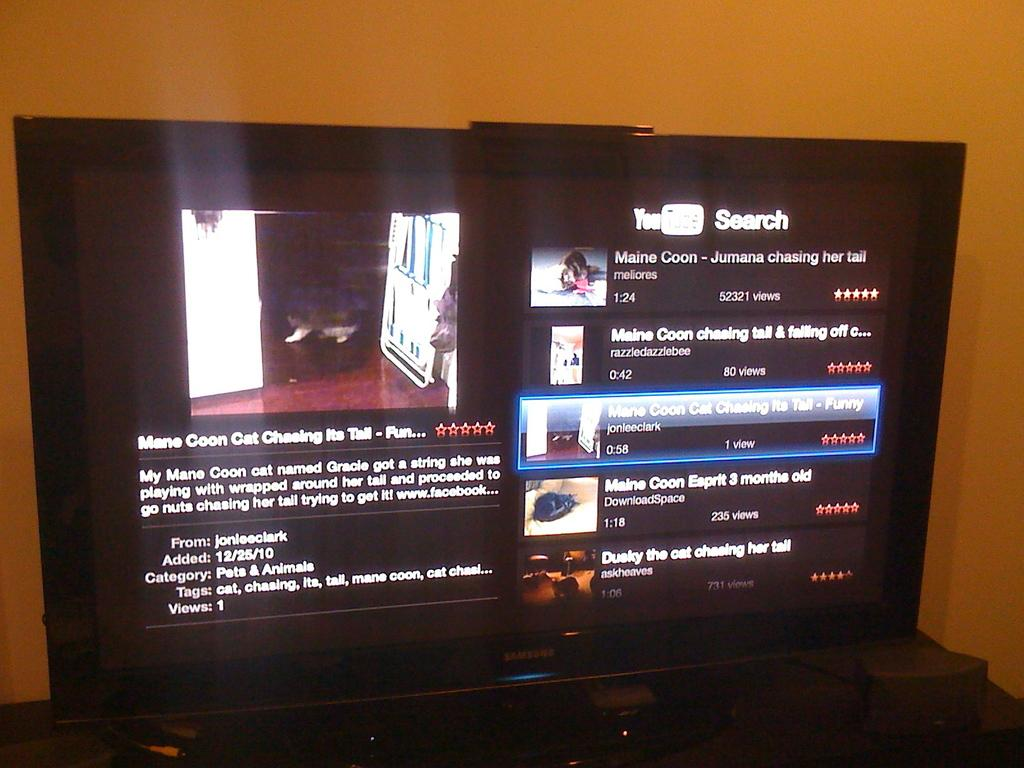<image>
Provide a brief description of the given image. A YouTube search screen displays the video "mane coon cat chasing its tail." 